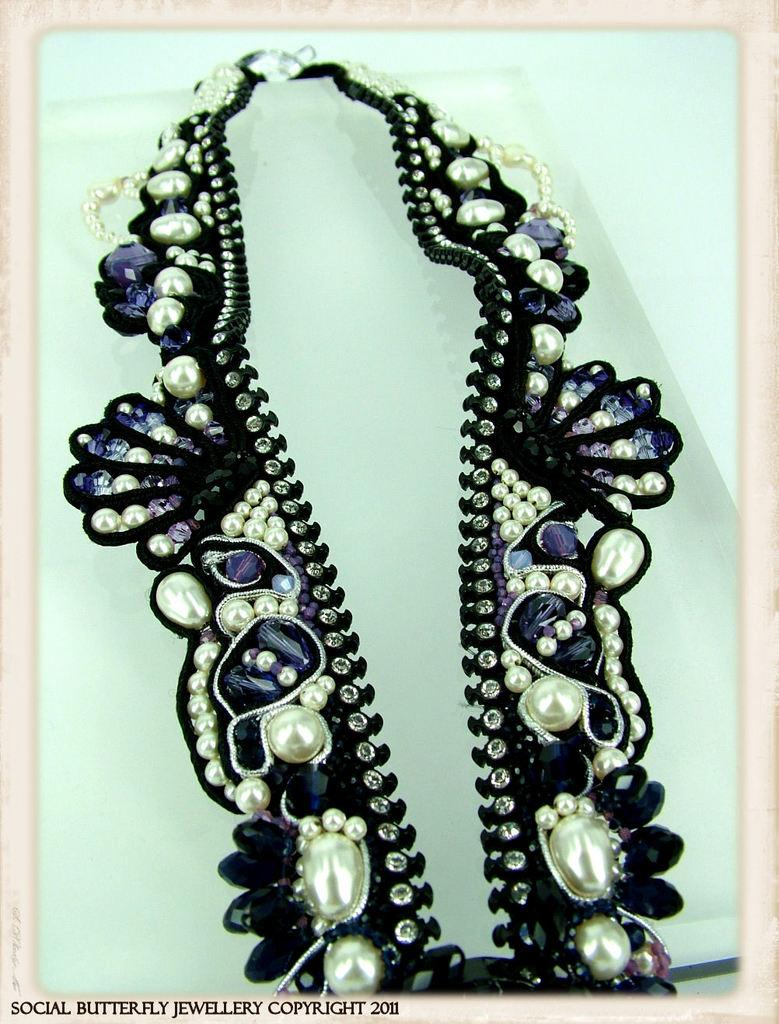What can be observed about the image that suggests it has been edited? The image appears to be edited. What is present on the object in the image? There is a necklace on an object in the image. What could be the purpose of the necklace in the image? The necklace may be a watermark on the image. What type of stomach ache is the baseball player experiencing in the image? There is no baseball player or stomach ache present in the image. What type of canvas is the necklace displayed on in the image? The image does not show a canvas, as it is a digital image. 